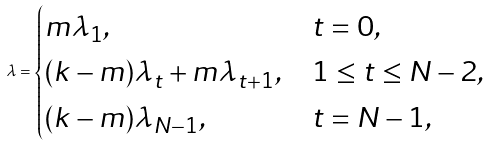Convert formula to latex. <formula><loc_0><loc_0><loc_500><loc_500>\lambda = \begin{cases} m \lambda _ { 1 } , & t = 0 , \\ ( k - m ) \lambda _ { t } + m \lambda _ { t + 1 } , & 1 \leq t \leq N - 2 , \\ ( k - m ) \lambda _ { N - 1 } , & t = N - 1 , \end{cases}</formula> 